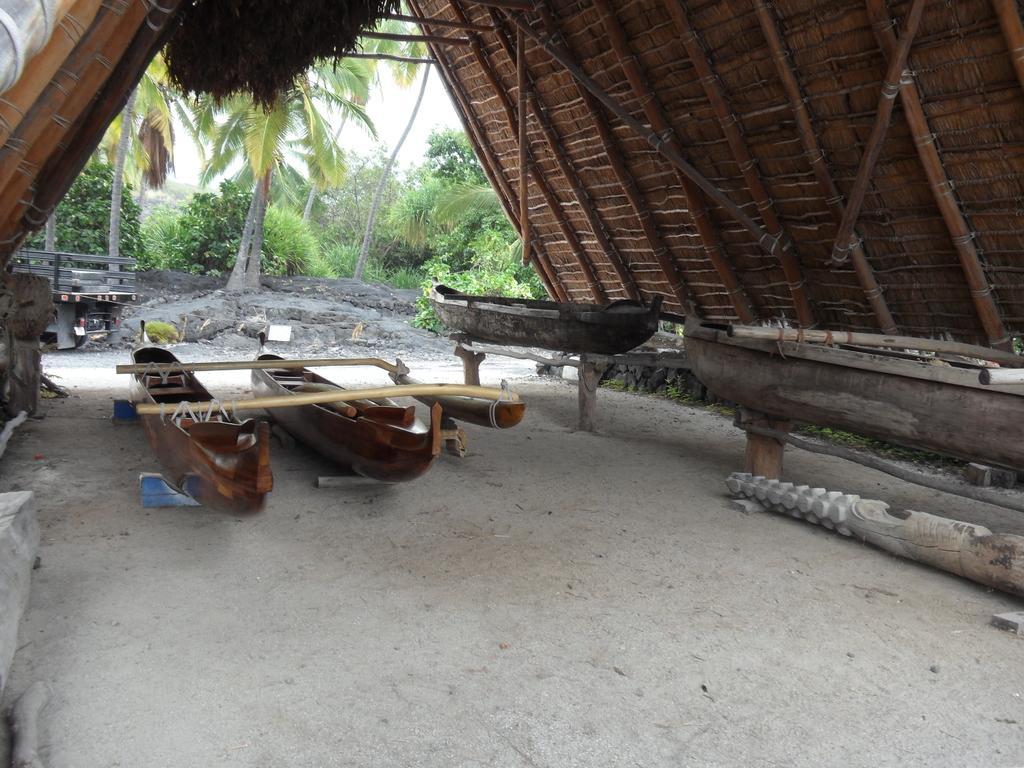Could you give a brief overview of what you see in this image? In this picture we can see a shed on the ground, here we can see boats, trees and some objects and we can see sky in the background. 